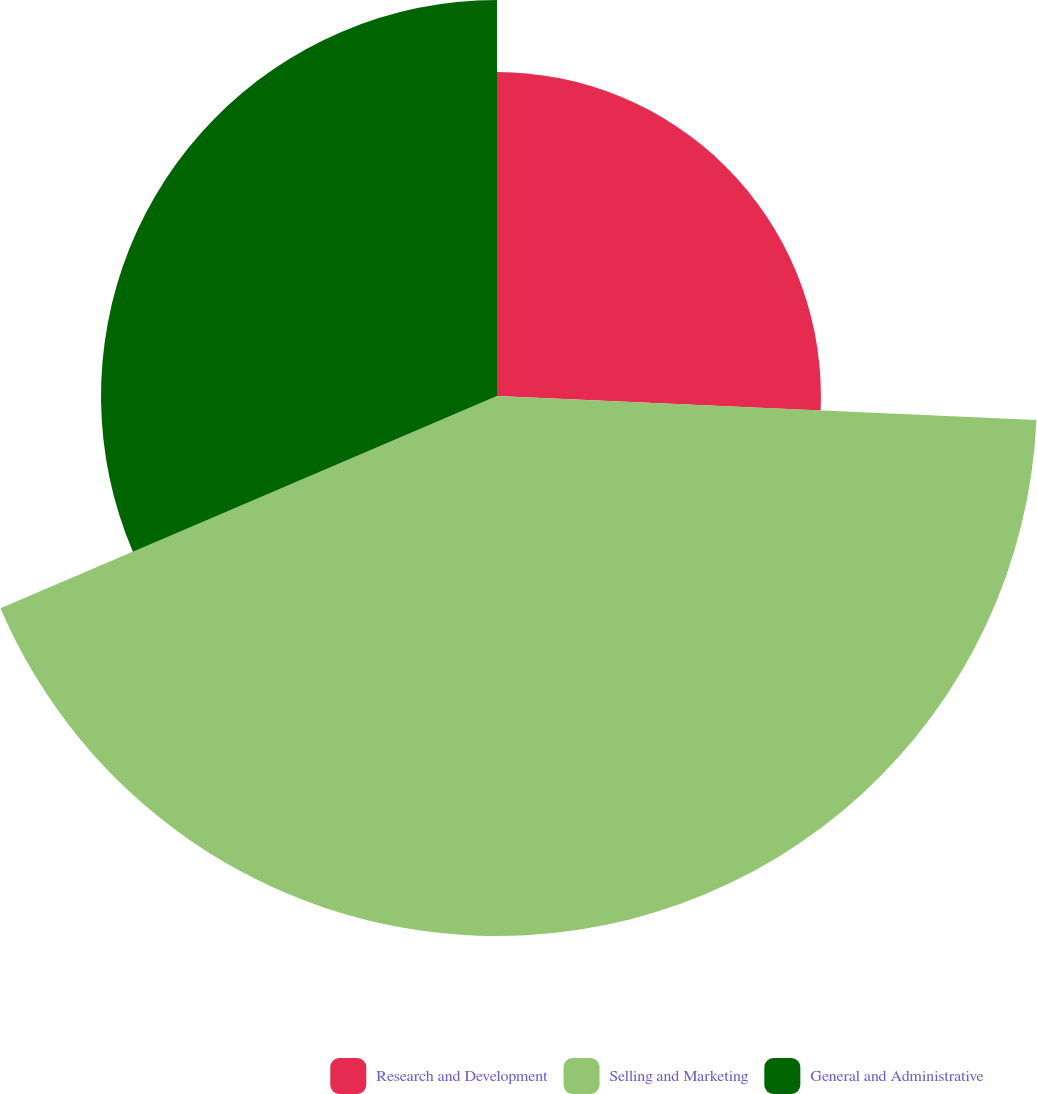Convert chart to OTSL. <chart><loc_0><loc_0><loc_500><loc_500><pie_chart><fcel>Research and Development<fcel>Selling and Marketing<fcel>General and Administrative<nl><fcel>25.71%<fcel>42.86%<fcel>31.43%<nl></chart> 